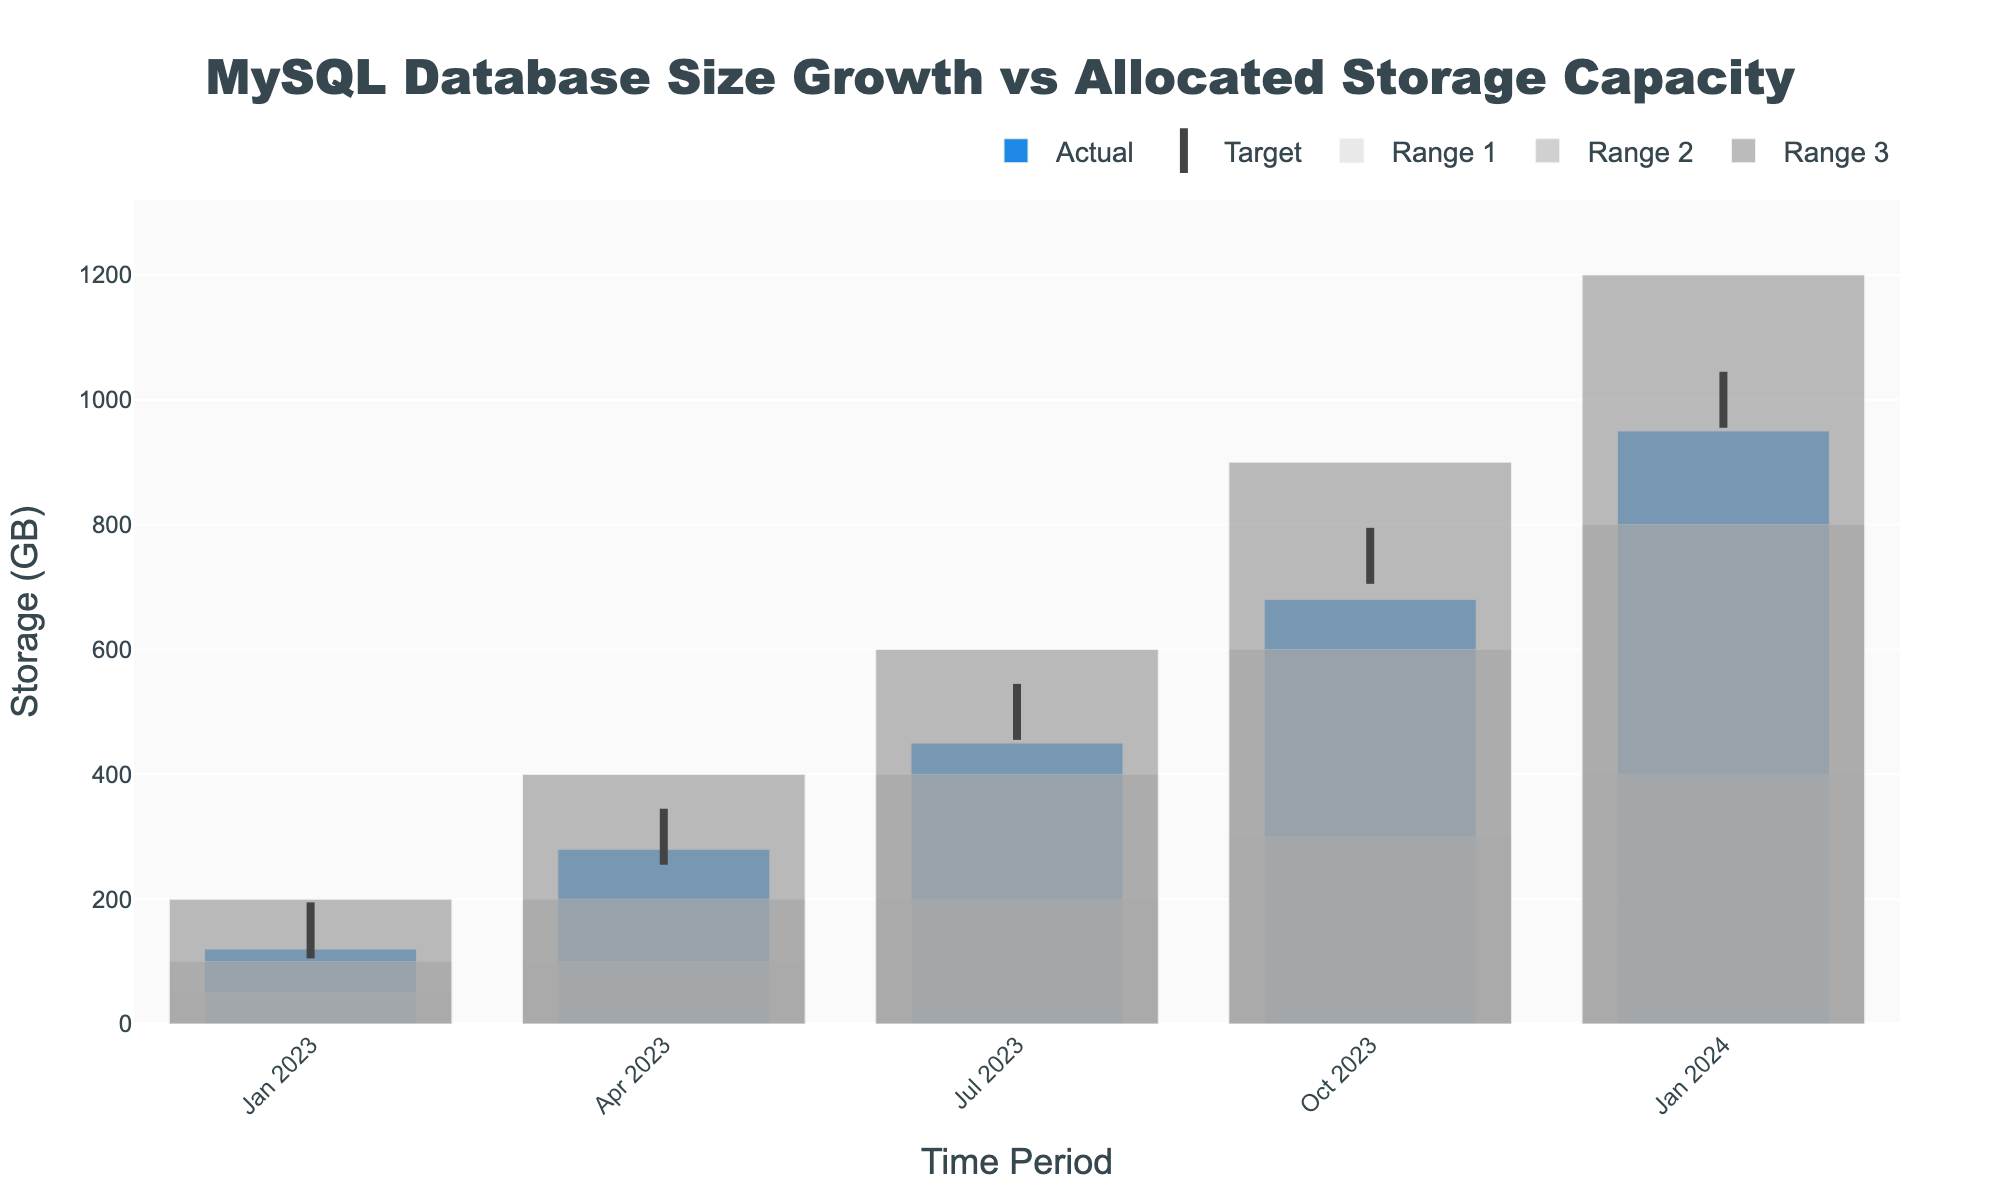What's the title of the chart? The title of the chart is positioned at the top and is formatted in a large, bold font. It reads "MySQL Database Size Growth vs Allocated Storage Capacity."
Answer: MySQL Database Size Growth vs Allocated Storage Capacity How many time periods are presented in the chart? The x-axis lists the time periods, and counting these points gives us the total number of periods. The periods are: Jan 2023, Apr 2023, Jul 2023, Oct 2023, and Jan 2024.
Answer: 5 In which time period is the actual database size closest to the target? By comparing the actual sizes and targets for each time period, the smallest difference occurs in Jan 2024 (950 GB vs 1000 GB: a difference of 50 GB).
Answer: Jan 2024 What is the range of values on the y-axis? Checking the y-axis, the scale starts at 0 and ends at around 1320 (1.1 times the maximum value of Range3 which is 1200 as mentioned in the code).
Answer: 0 to 1320 How does the actual database size in Jul 2023 compare to the highest range value for that period? The actual size in Jul 2023 is 450 GB. The highest range (Range 3) for Jul 2023 is 600 GB. So, 450 GB is less than 600 GB.
Answer: Less than Which time period saw the largest increase in actual database size compared to the previous period? By examining each actual size and calculating the differences:
- Jan 2023 to Apr 2023: 280 - 120 = 160 GB
- Apr 2023 to Jul 2023: 450 - 280 = 170 GB
- Jul 2023 to Oct 2023: 680 - 450 = 230 GB
- Oct 2023 to Jan 2024: 950 - 680 = 270 GB
The largest increase is from Oct to Jan 2024, which is 270 GB.
Answer: Oct 2023 to Jan 2024 What colors are used to represent the different ranges in the chart? Observing the different bars representing ranges, they use various shades of grey: Range 1 is lighter grey, Range 2 is medium grey, and Range 3 is darker grey.
Answer: Light grey, medium grey, dark grey What's the difference between the target and actual database size in Apr 2023? The target size in Apr 2023 is 300 GB, and the actual size is 280 GB. The difference is calculated as 300 - 280 = 20 GB.
Answer: 20 GB Which range does the actual database size fall into for Jan 2023? Observing Jan 2023 data, the actual size is 120 GB and the ranges are: Range 1 (0-50 GB), Range 2 (51-100 GB), Range 3 (101-200 GB). Therefore, 120 GB falls in Range 3.
Answer: Range 3 